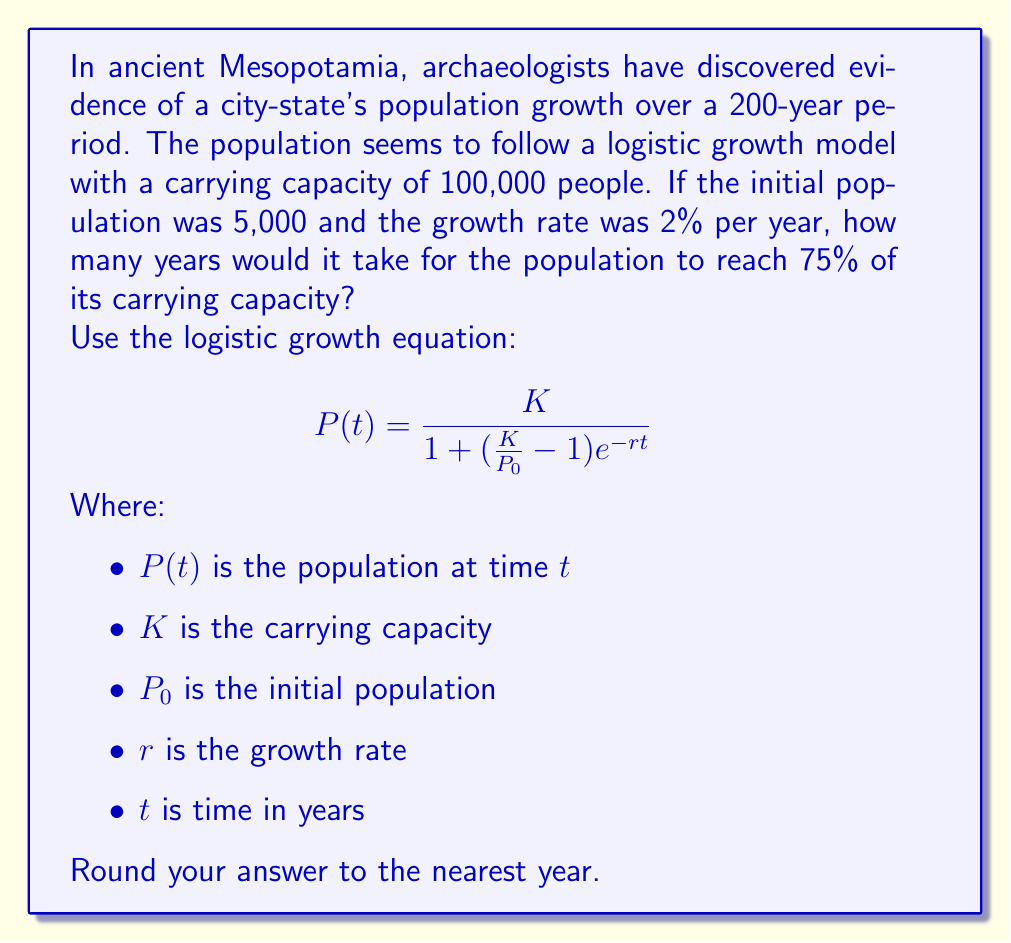Can you solve this math problem? To solve this problem, we need to use the logistic growth equation and solve for $t$ when the population reaches 75% of the carrying capacity. Let's approach this step-by-step:

1) First, let's identify our known values:
   $K = 100,000$ (carrying capacity)
   $P_0 = 5,000$ (initial population)
   $r = 0.02$ (2% growth rate)
   $P(t) = 0.75K = 75,000$ (75% of carrying capacity)

2) Now, let's substitute these values into the logistic growth equation:

   $$75,000 = \frac{100,000}{1 + (\frac{100,000}{5,000} - 1)e^{-0.02t}}$$

3) Simplify:
   $$75,000 = \frac{100,000}{1 + 19e^{-0.02t}}$$

4) Multiply both sides by the denominator:
   $$75,000(1 + 19e^{-0.02t}) = 100,000$$

5) Distribute on the left side:
   $$75,000 + 1,425,000e^{-0.02t} = 100,000$$

6) Subtract 75,000 from both sides:
   $$1,425,000e^{-0.02t} = 25,000$$

7) Divide both sides by 1,425,000:
   $$e^{-0.02t} = \frac{25,000}{1,425,000} = \frac{1}{57}$$

8) Take the natural log of both sides:
   $$-0.02t = \ln(\frac{1}{57})$$

9) Divide both sides by -0.02:
   $$t = \frac{\ln(\frac{1}{57})}{-0.02} = \frac{\ln(57)}{0.02}$$

10) Calculate the result:
    $$t \approx 201.13$$

11) Rounding to the nearest year:
    $$t = 201 \text{ years}$$
Answer: 201 years 